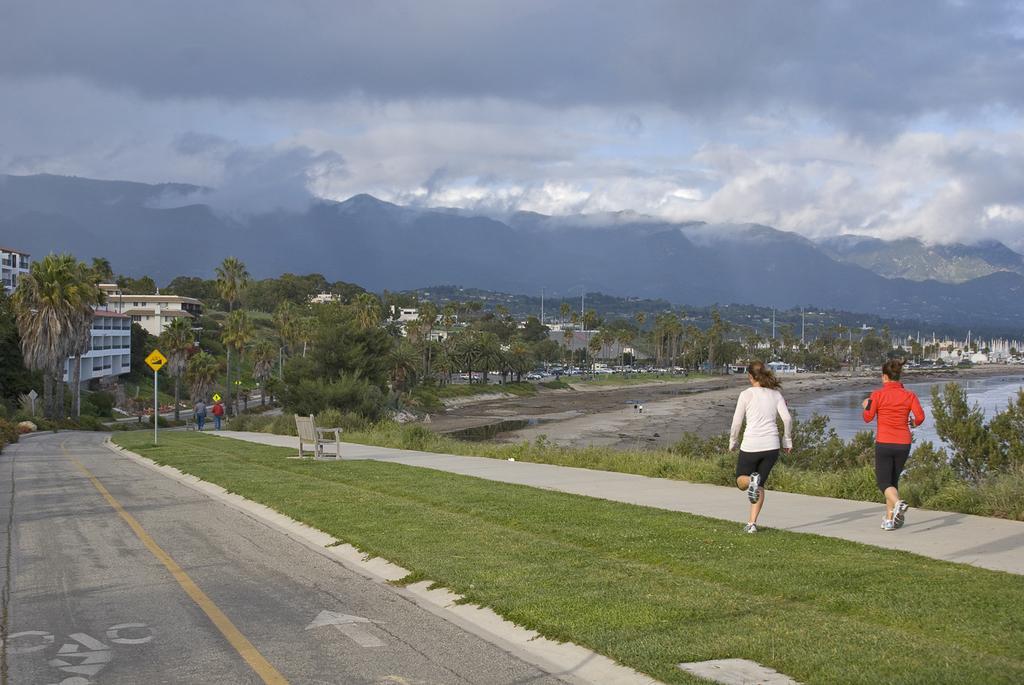In one or two sentences, can you explain what this image depicts? In the picture we can see a part of the road, beside it, we can see a grass surface and on it we can see a pole with a board and a bench and we can see two people are jogging on the surface and in the background we can see the water, trees, buildings and the sky with clouds. 